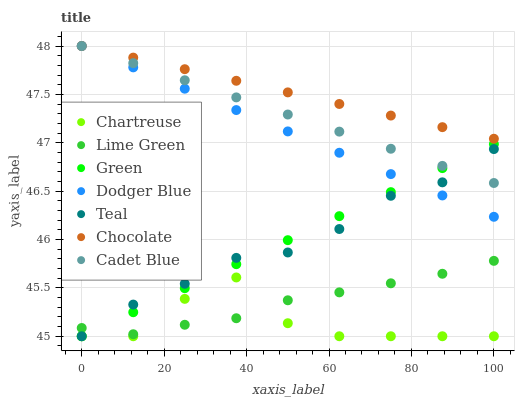Does Chartreuse have the minimum area under the curve?
Answer yes or no. Yes. Does Chocolate have the maximum area under the curve?
Answer yes or no. Yes. Does Chocolate have the minimum area under the curve?
Answer yes or no. No. Does Chartreuse have the maximum area under the curve?
Answer yes or no. No. Is Chocolate the smoothest?
Answer yes or no. Yes. Is Chartreuse the roughest?
Answer yes or no. Yes. Is Chartreuse the smoothest?
Answer yes or no. No. Is Chocolate the roughest?
Answer yes or no. No. Does Chartreuse have the lowest value?
Answer yes or no. Yes. Does Chocolate have the lowest value?
Answer yes or no. No. Does Dodger Blue have the highest value?
Answer yes or no. Yes. Does Chartreuse have the highest value?
Answer yes or no. No. Is Green less than Chocolate?
Answer yes or no. Yes. Is Cadet Blue greater than Lime Green?
Answer yes or no. Yes. Does Cadet Blue intersect Dodger Blue?
Answer yes or no. Yes. Is Cadet Blue less than Dodger Blue?
Answer yes or no. No. Is Cadet Blue greater than Dodger Blue?
Answer yes or no. No. Does Green intersect Chocolate?
Answer yes or no. No. 